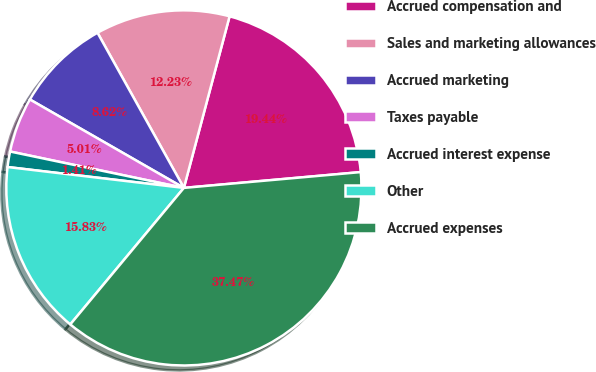Convert chart. <chart><loc_0><loc_0><loc_500><loc_500><pie_chart><fcel>Accrued compensation and<fcel>Sales and marketing allowances<fcel>Accrued marketing<fcel>Taxes payable<fcel>Accrued interest expense<fcel>Other<fcel>Accrued expenses<nl><fcel>19.44%<fcel>12.23%<fcel>8.62%<fcel>5.01%<fcel>1.41%<fcel>15.83%<fcel>37.47%<nl></chart> 